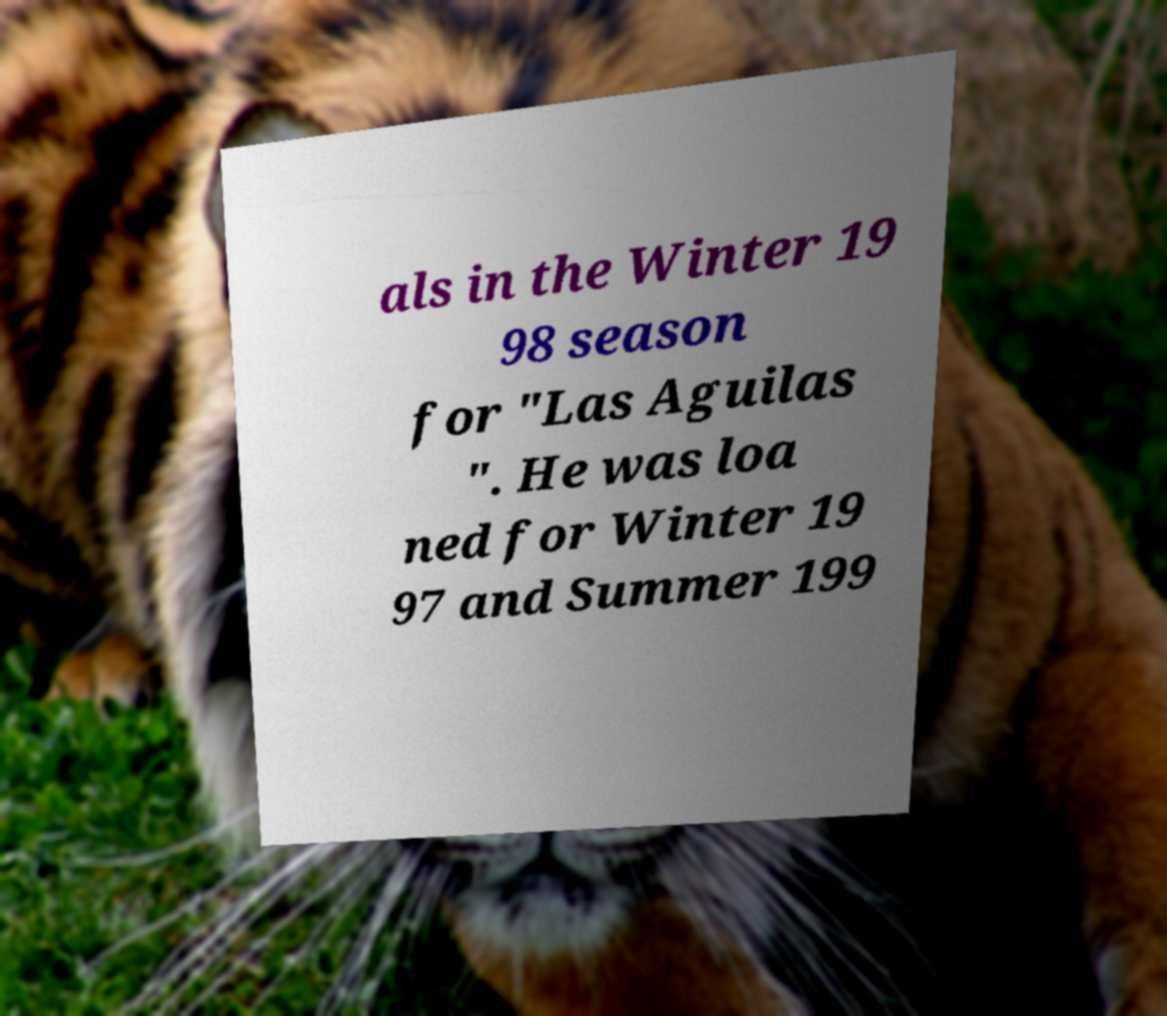Can you accurately transcribe the text from the provided image for me? als in the Winter 19 98 season for "Las Aguilas ". He was loa ned for Winter 19 97 and Summer 199 